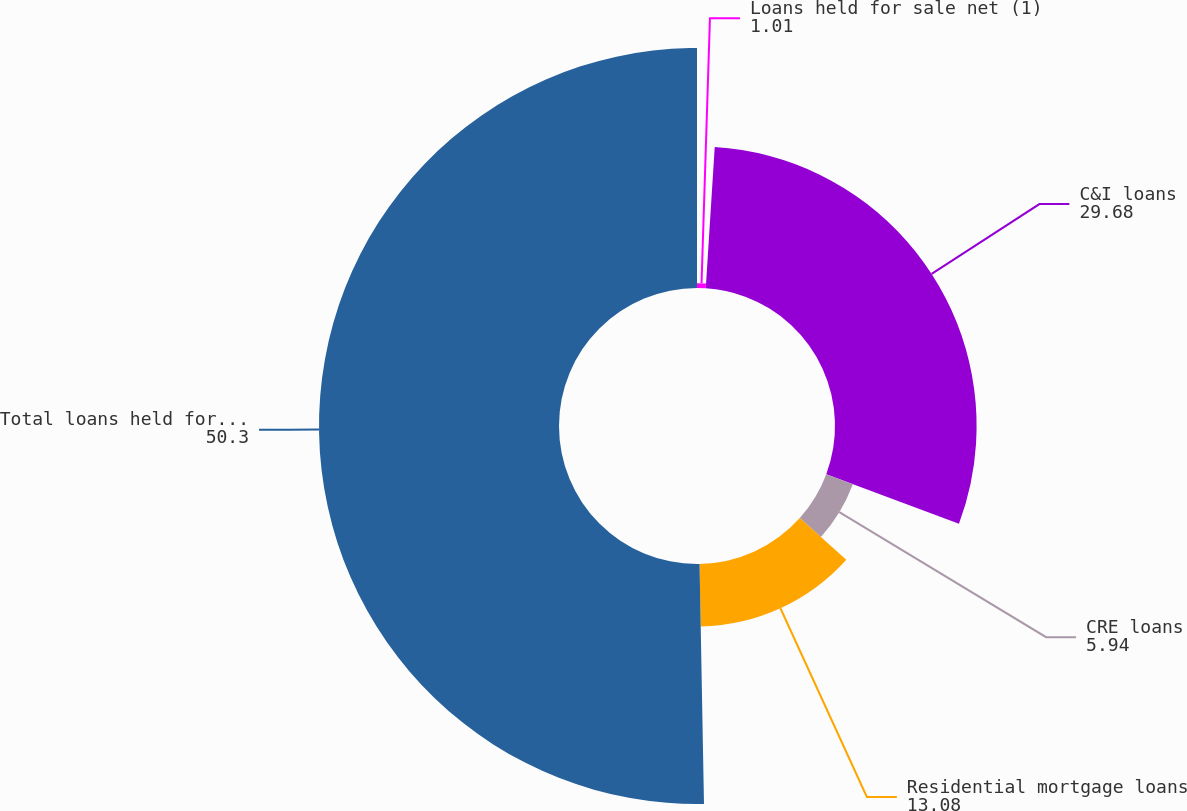<chart> <loc_0><loc_0><loc_500><loc_500><pie_chart><fcel>Loans held for sale net (1)<fcel>C&I loans<fcel>CRE loans<fcel>Residential mortgage loans<fcel>Total loans held for sale and<nl><fcel>1.01%<fcel>29.68%<fcel>5.94%<fcel>13.08%<fcel>50.3%<nl></chart> 